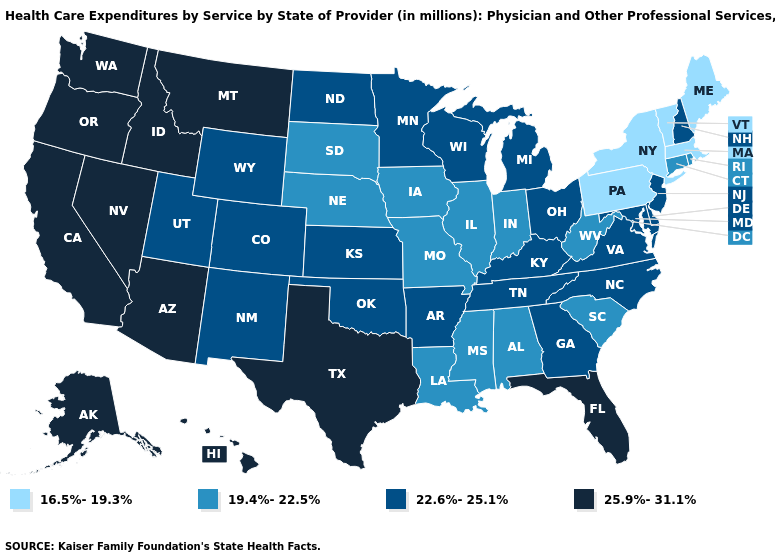Name the states that have a value in the range 22.6%-25.1%?
Write a very short answer. Arkansas, Colorado, Delaware, Georgia, Kansas, Kentucky, Maryland, Michigan, Minnesota, New Hampshire, New Jersey, New Mexico, North Carolina, North Dakota, Ohio, Oklahoma, Tennessee, Utah, Virginia, Wisconsin, Wyoming. Does Massachusetts have the lowest value in the Northeast?
Write a very short answer. Yes. What is the value of Wisconsin?
Concise answer only. 22.6%-25.1%. Name the states that have a value in the range 22.6%-25.1%?
Write a very short answer. Arkansas, Colorado, Delaware, Georgia, Kansas, Kentucky, Maryland, Michigan, Minnesota, New Hampshire, New Jersey, New Mexico, North Carolina, North Dakota, Ohio, Oklahoma, Tennessee, Utah, Virginia, Wisconsin, Wyoming. What is the value of Oregon?
Write a very short answer. 25.9%-31.1%. What is the value of Oregon?
Concise answer only. 25.9%-31.1%. What is the lowest value in states that border Mississippi?
Write a very short answer. 19.4%-22.5%. Name the states that have a value in the range 25.9%-31.1%?
Answer briefly. Alaska, Arizona, California, Florida, Hawaii, Idaho, Montana, Nevada, Oregon, Texas, Washington. What is the value of Tennessee?
Concise answer only. 22.6%-25.1%. Name the states that have a value in the range 25.9%-31.1%?
Be succinct. Alaska, Arizona, California, Florida, Hawaii, Idaho, Montana, Nevada, Oregon, Texas, Washington. What is the lowest value in the MidWest?
Be succinct. 19.4%-22.5%. Does South Dakota have a lower value than New Hampshire?
Be succinct. Yes. Name the states that have a value in the range 22.6%-25.1%?
Keep it brief. Arkansas, Colorado, Delaware, Georgia, Kansas, Kentucky, Maryland, Michigan, Minnesota, New Hampshire, New Jersey, New Mexico, North Carolina, North Dakota, Ohio, Oklahoma, Tennessee, Utah, Virginia, Wisconsin, Wyoming. What is the highest value in states that border South Carolina?
Concise answer only. 22.6%-25.1%. Name the states that have a value in the range 16.5%-19.3%?
Write a very short answer. Maine, Massachusetts, New York, Pennsylvania, Vermont. 